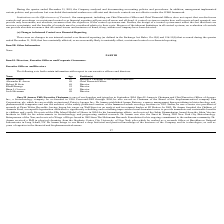According to Protagenic Therapeutics's financial document, Who is the Executive chairman of the Board of Directors? According to the financial document, Garo H. Armen. The relevant text states: "Garo H. Armen 67 Executive Chairman of the Board of Directors..." Also, Who is the Chief Financial Officer of the company? According to the financial document, Alexander K. Arrow. The relevant text states: "Alexander K. Arrow 49 Chief Financial Officer..." Also, When did the Executive Chairman join the company? According to the financial document, September 2004. The relevant text states: "Chairman, is one of our founders and joined us in September 2004. Garo H. Armen is Chairman and Chief Executive Officer of Agenus..." Also, How many directors are there in the company? Counting the relevant items in the document: Robert B. Stein ,  Khalil Barrage ,  Brian J. Corvese ,  Josh Silverman, I find 4 instances. The key data points involved are: Brian J. Corvese, Josh Silverman, Khalil Barrage. Also, can you calculate: What is the average age of the directors in the company? To answer this question, I need to perform calculations using the financial data. The calculation is: (69 + 55 + 62 + 49)/4 , which equals 58.75. This is based on the information: "Brian J. Corvese 62 Director Alexander K. Arrow 49 Chief Financial Officer Robert B. Stein 69 Director Khalil Barrage 55 Director..." The key data points involved are: 49, 55, 62. Additionally, Who is the oldest director within the company's Board of Directors? According to the financial document, Robert B. Stein. The relevant text states: "Robert B. Stein 69 Director..." 